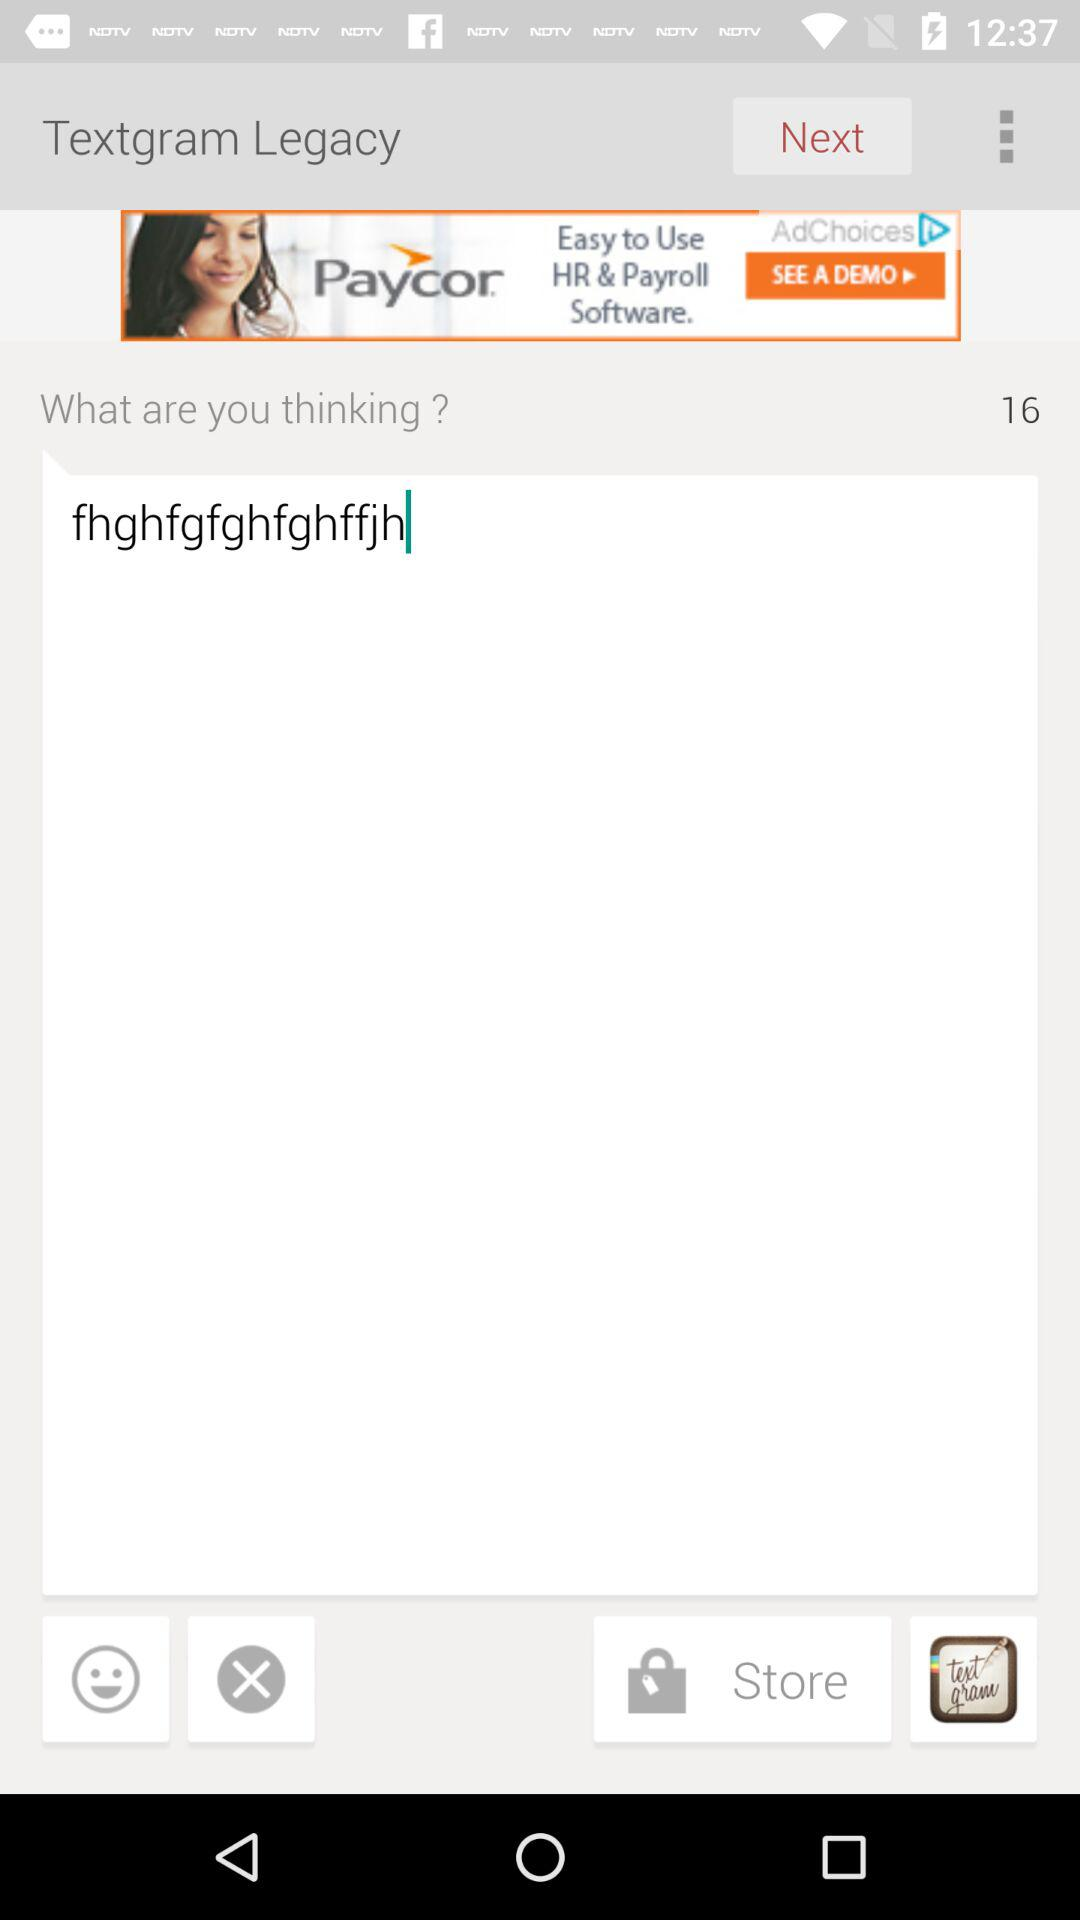How many sentences have been typed?
When the provided information is insufficient, respond with <no answer>. <no answer> 